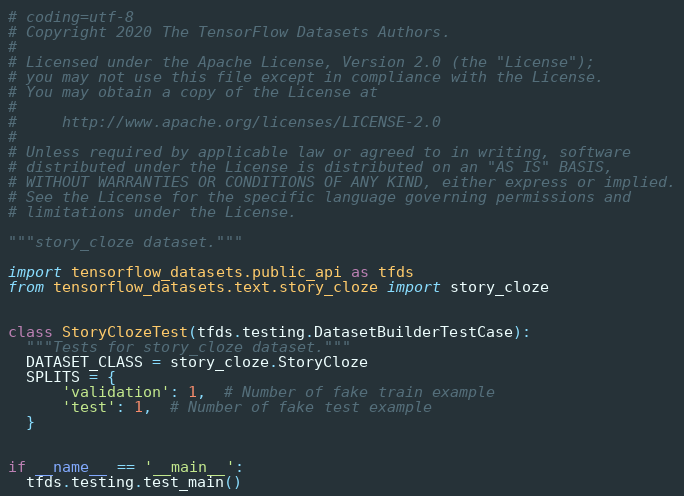Convert code to text. <code><loc_0><loc_0><loc_500><loc_500><_Python_># coding=utf-8
# Copyright 2020 The TensorFlow Datasets Authors.
#
# Licensed under the Apache License, Version 2.0 (the "License");
# you may not use this file except in compliance with the License.
# You may obtain a copy of the License at
#
#     http://www.apache.org/licenses/LICENSE-2.0
#
# Unless required by applicable law or agreed to in writing, software
# distributed under the License is distributed on an "AS IS" BASIS,
# WITHOUT WARRANTIES OR CONDITIONS OF ANY KIND, either express or implied.
# See the License for the specific language governing permissions and
# limitations under the License.

"""story_cloze dataset."""

import tensorflow_datasets.public_api as tfds
from tensorflow_datasets.text.story_cloze import story_cloze


class StoryClozeTest(tfds.testing.DatasetBuilderTestCase):
  """Tests for story_cloze dataset."""
  DATASET_CLASS = story_cloze.StoryCloze
  SPLITS = {
      'validation': 1,  # Number of fake train example
      'test': 1,  # Number of fake test example
  }


if __name__ == '__main__':
  tfds.testing.test_main()
</code> 